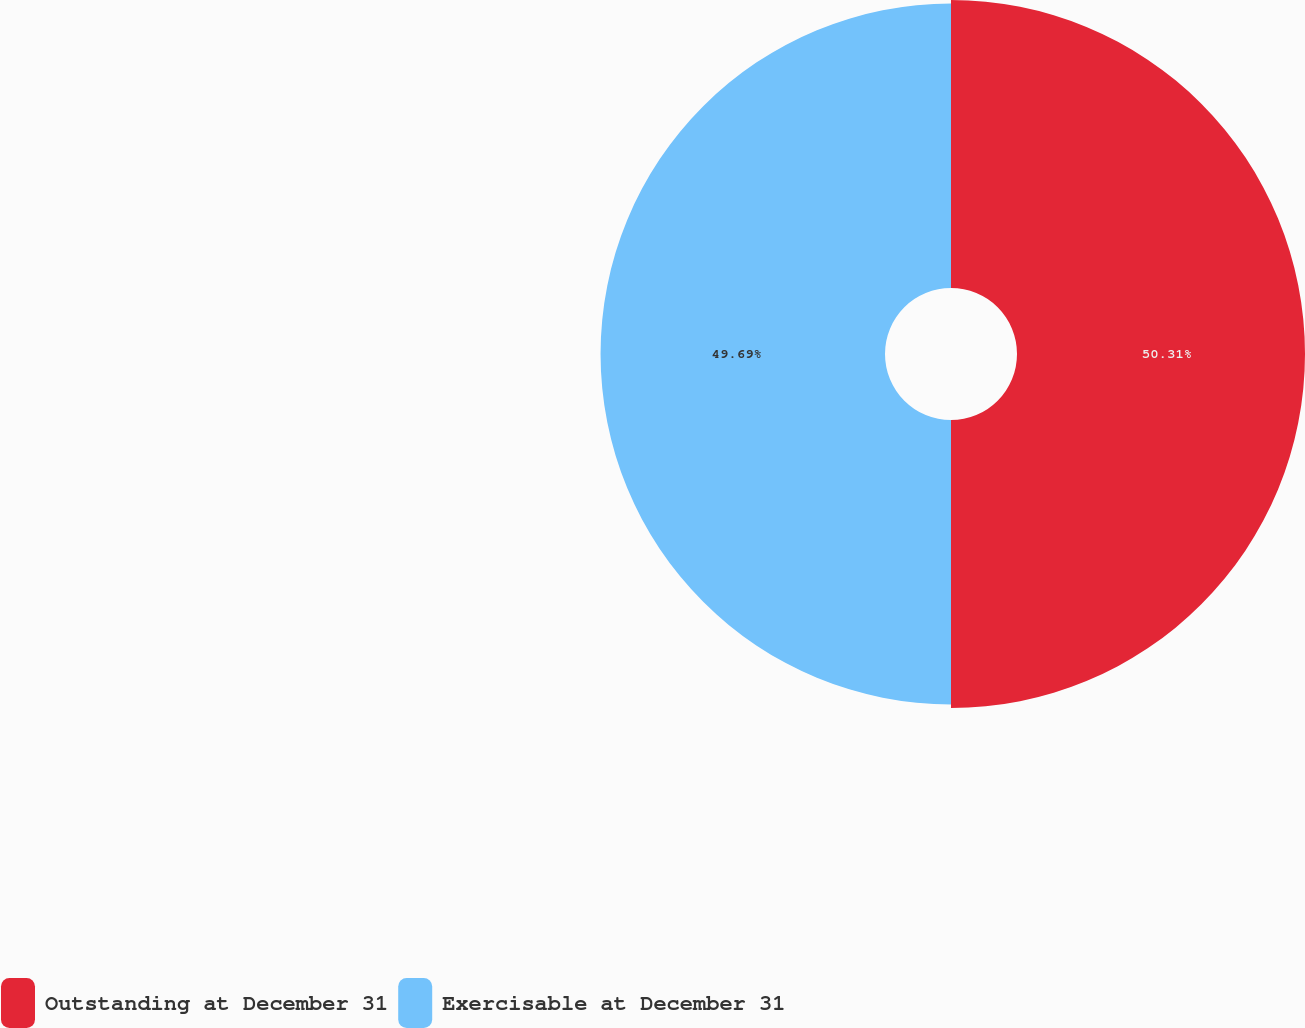<chart> <loc_0><loc_0><loc_500><loc_500><pie_chart><fcel>Outstanding at December 31<fcel>Exercisable at December 31<nl><fcel>50.31%<fcel>49.69%<nl></chart> 